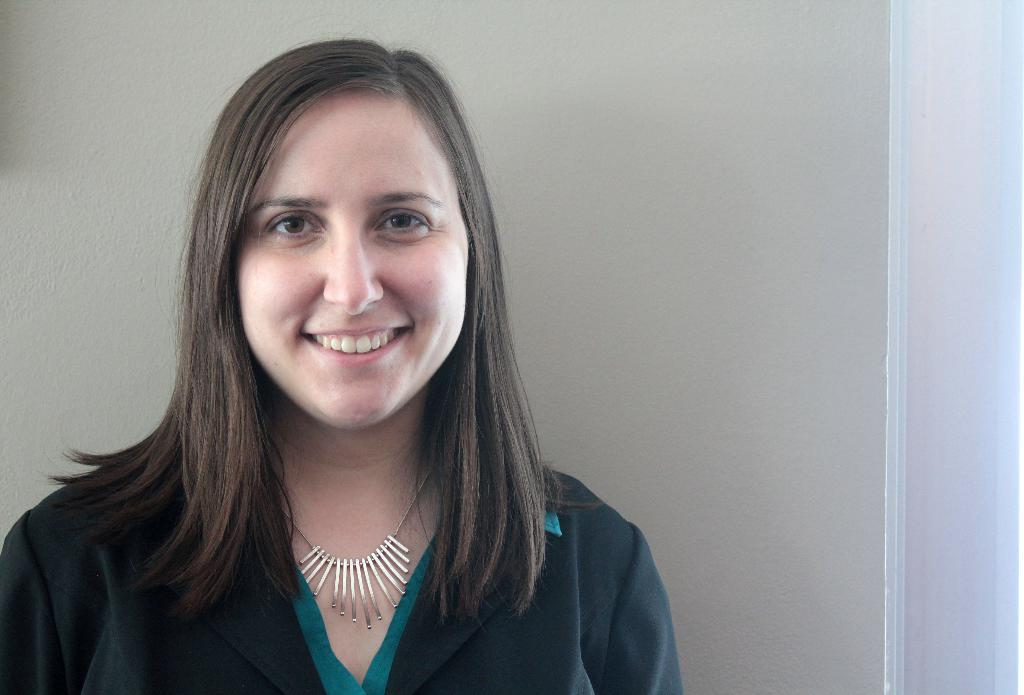Who is present in the image? There is a woman in the image. What is the woman wearing? The woman is wearing a green and black dress. What expression does the woman have? The woman is smiling. What can be seen in the background of the image? There is a white wall in the background of the image. What is the name of the sheep in the image? There is no sheep present in the image. How many buckets are visible in the image? There are no buckets visible in the image. 